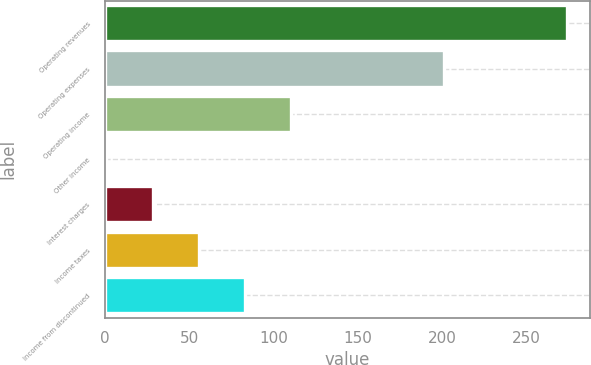Convert chart. <chart><loc_0><loc_0><loc_500><loc_500><bar_chart><fcel>Operating revenues<fcel>Operating expenses<fcel>Operating income<fcel>Other income<fcel>Interest charges<fcel>Income taxes<fcel>Income from discontinued<nl><fcel>274<fcel>201<fcel>110.2<fcel>1<fcel>28.3<fcel>55.6<fcel>82.9<nl></chart> 